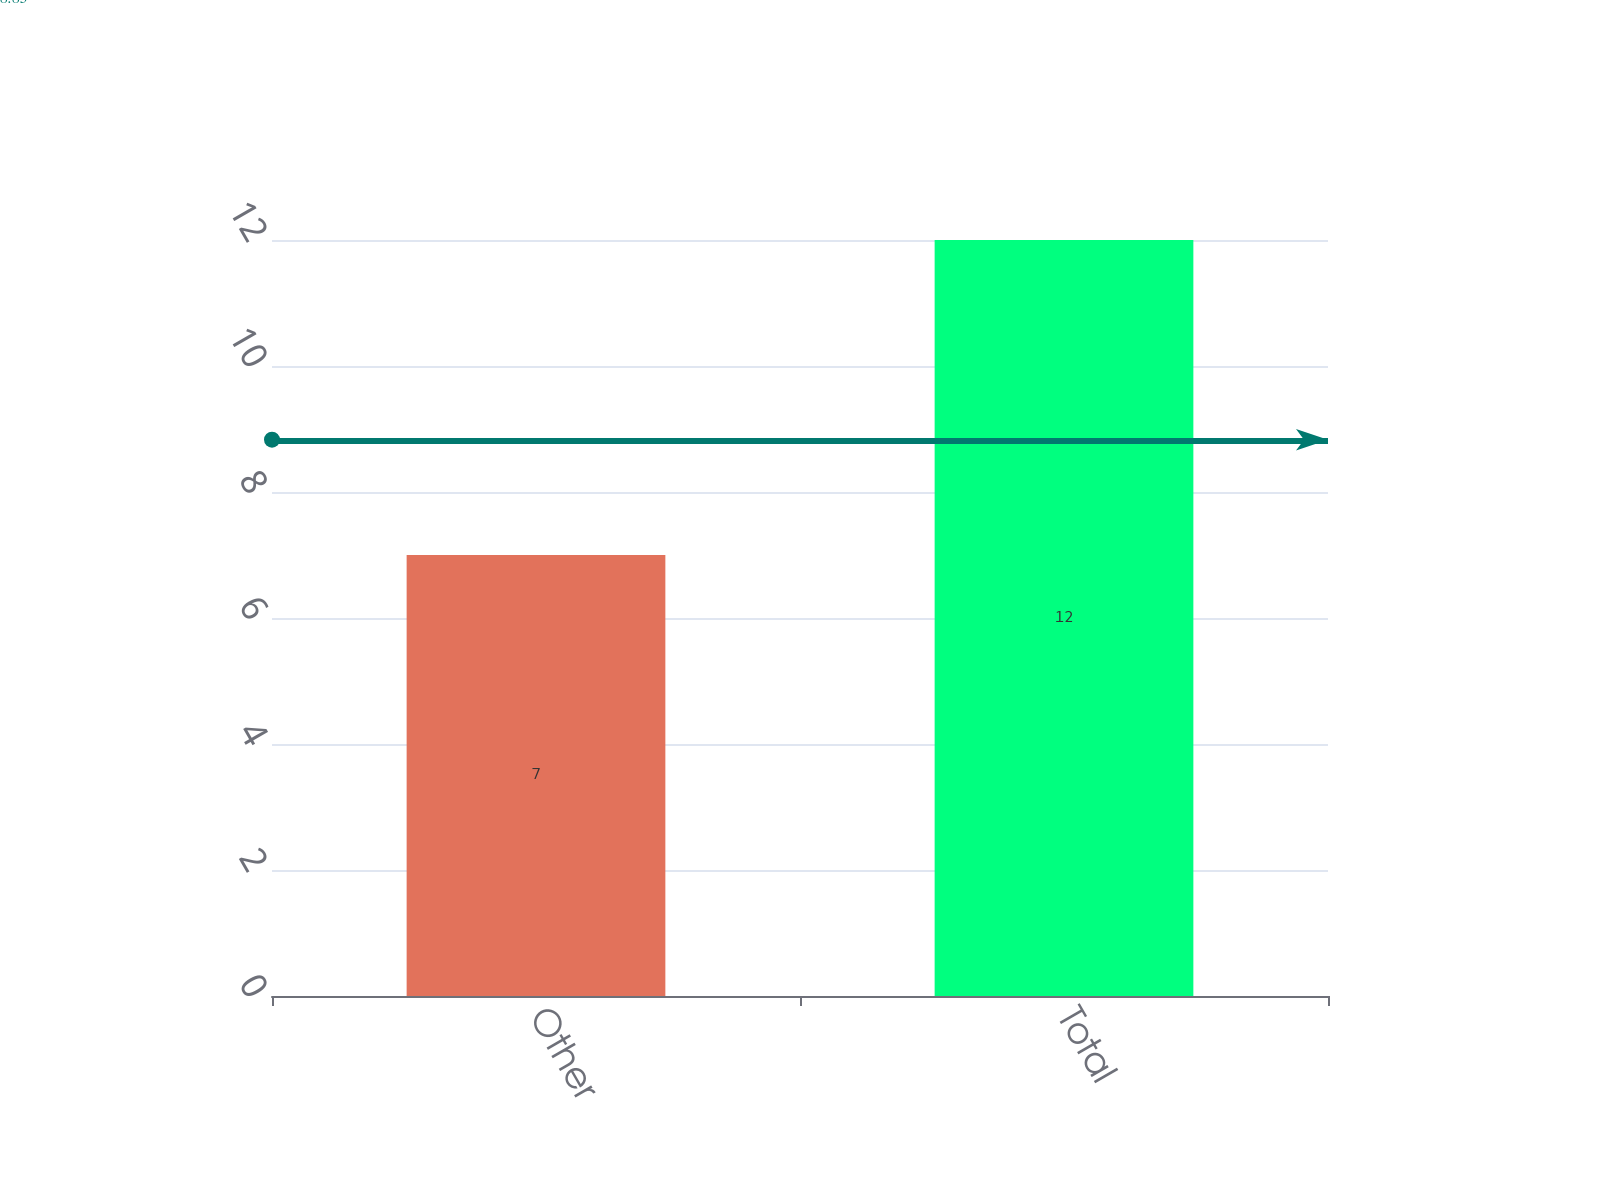Convert chart. <chart><loc_0><loc_0><loc_500><loc_500><bar_chart><fcel>Other<fcel>Total<nl><fcel>7<fcel>12<nl></chart> 